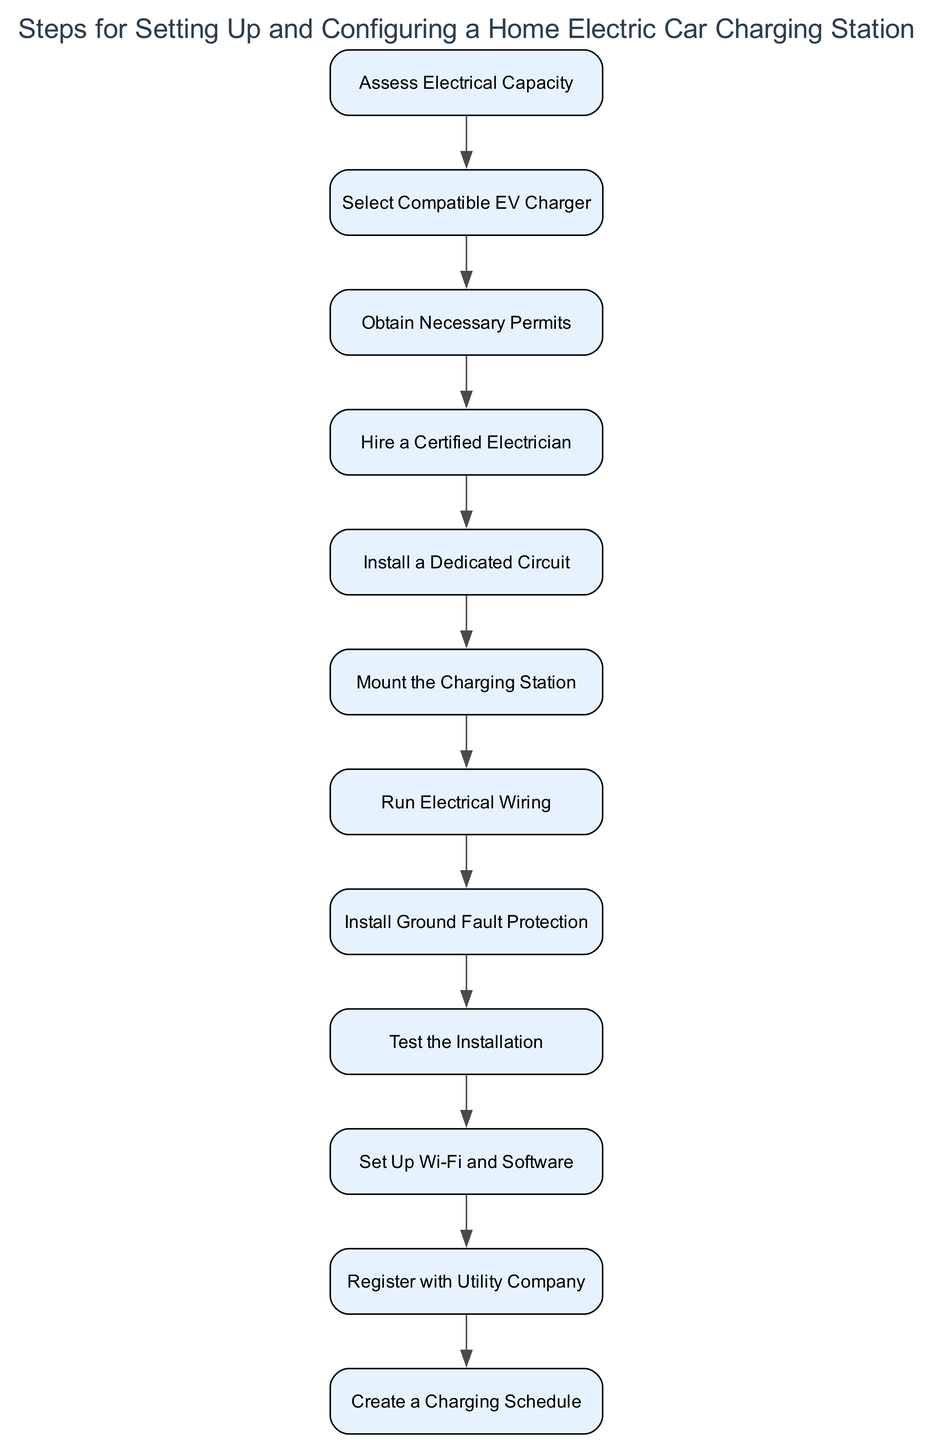What is the first step in the installation process? The first step in the installation process is listed at the top of the diagram, which is "Assess Electrical Capacity." This is the initial step that one must take before proceeding to other tasks.
Answer: Assess Electrical Capacity How many steps are there in total? By counting each individual step represented in the diagram, we find that there are 12 distinct steps outlined for setting up a home electric car charging station.
Answer: 12 What step comes after "Select Compatible EV Charger"? The step that comes immediately after "Select Compatible EV Charger" is "Obtain Necessary Permits." This can be determined by looking at the flow from one step to the next in the diagram.
Answer: Obtain Necessary Permits Which step requires hiring a professional? The step that requires hiring a professional is "Hire a Certified Electrician." This is explicitly stated in the diagram as a necessary preparation for the installation of the EV charger.
Answer: Hire a Certified Electrician What step involves installing safety features? The step that involves installing safety features is "Install Ground Fault Protection." This is a vital step for ensuring the safety of the charging process as indicated in the diagram.
Answer: Install Ground Fault Protection What is the last step in the setup process? The last step in the setup process is "Create a Charging Schedule." This step appears at the bottom of the flowchart, indicating it is the final action to be taken after all previous steps are completed.
Answer: Create a Charging Schedule What two steps are needed before the installation can begin? The two steps needed before installation can begin are "Select Compatible EV Charger" and "Obtain Necessary Permits." These steps must be completed prior to hiring an electrician for the installation.
Answer: Select Compatible EV Charger, Obtain Necessary Permits What action should be taken after running electrical wiring? After running electrical wiring, the next action to take is "Install Ground Fault Protection." This flow indicates that wiring must be completed before implementing safety features.
Answer: Install Ground Fault Protection 